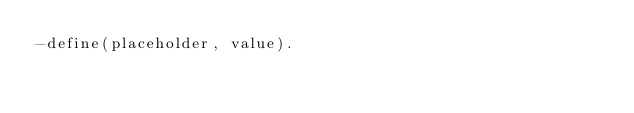<code> <loc_0><loc_0><loc_500><loc_500><_Erlang_>-define(placeholder, value).
</code> 